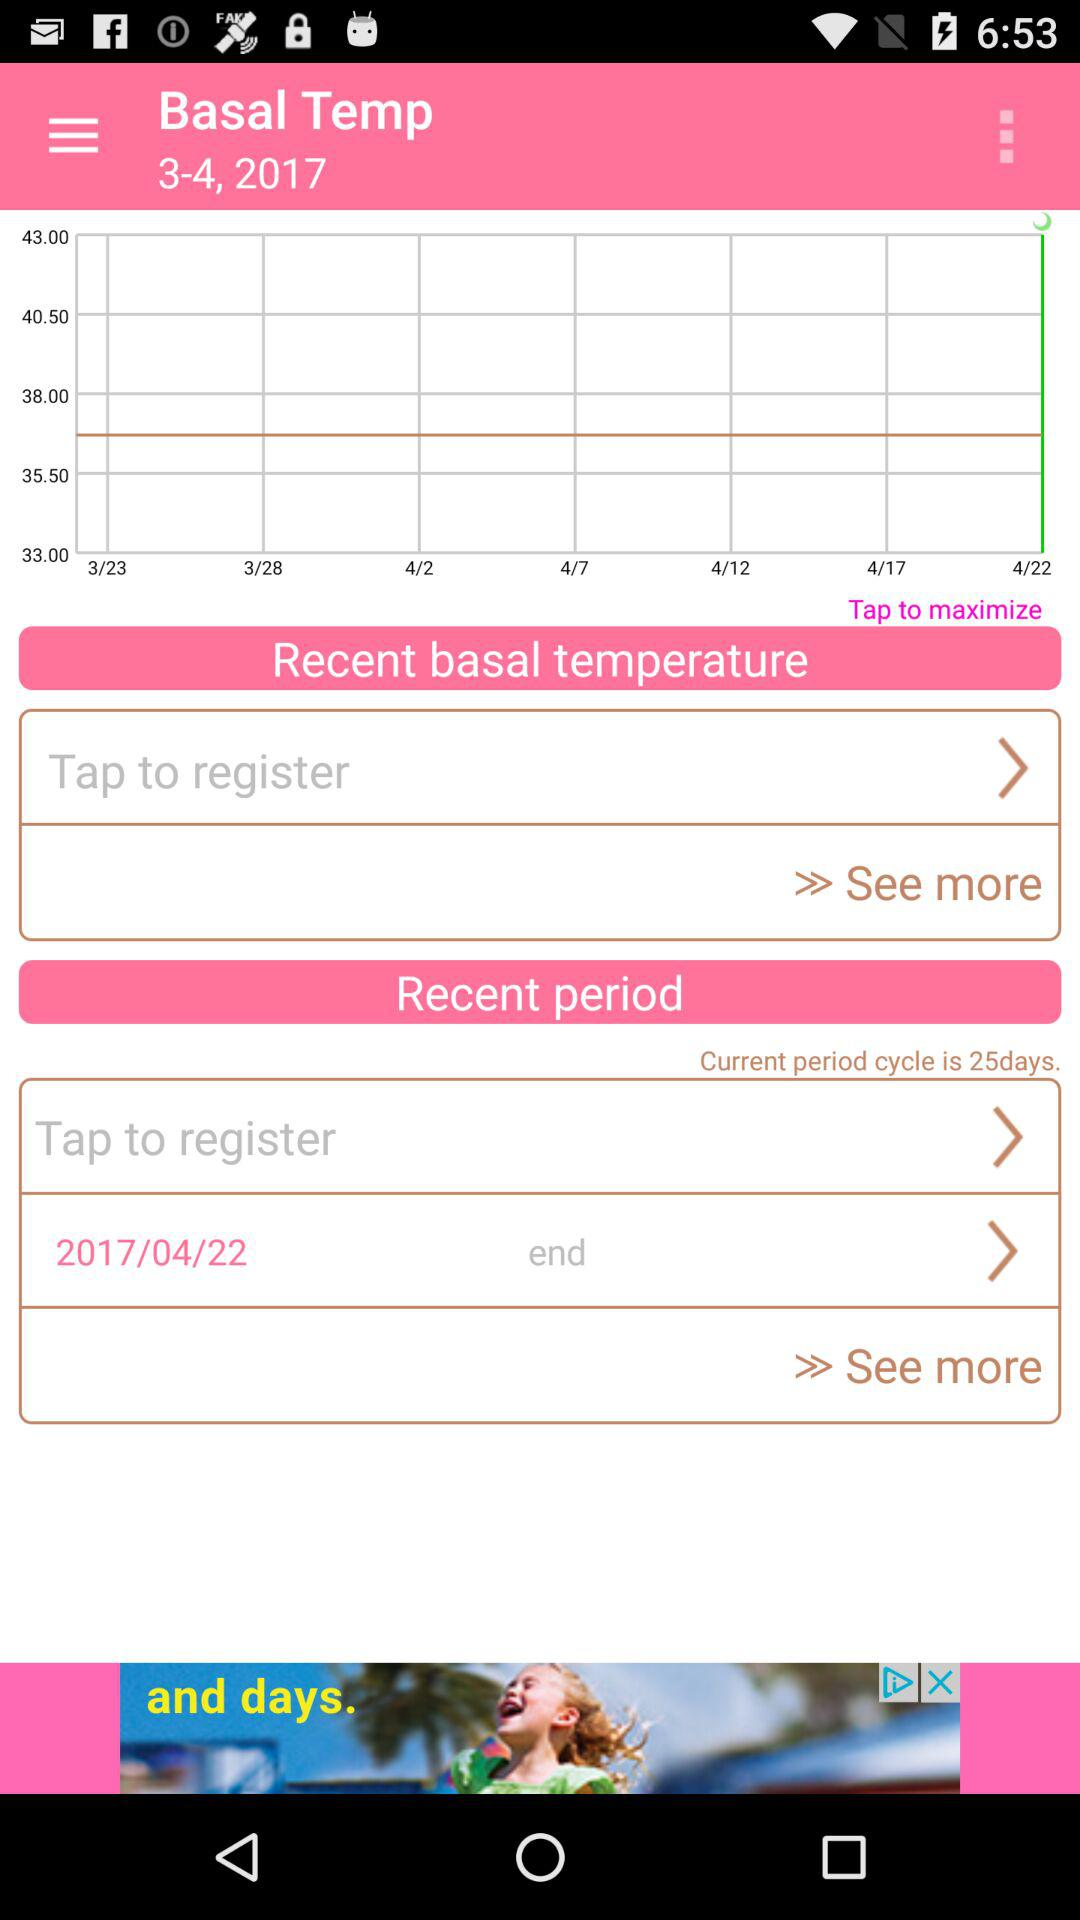How long is the current period cycle? The current period cycle is 25 days long. 